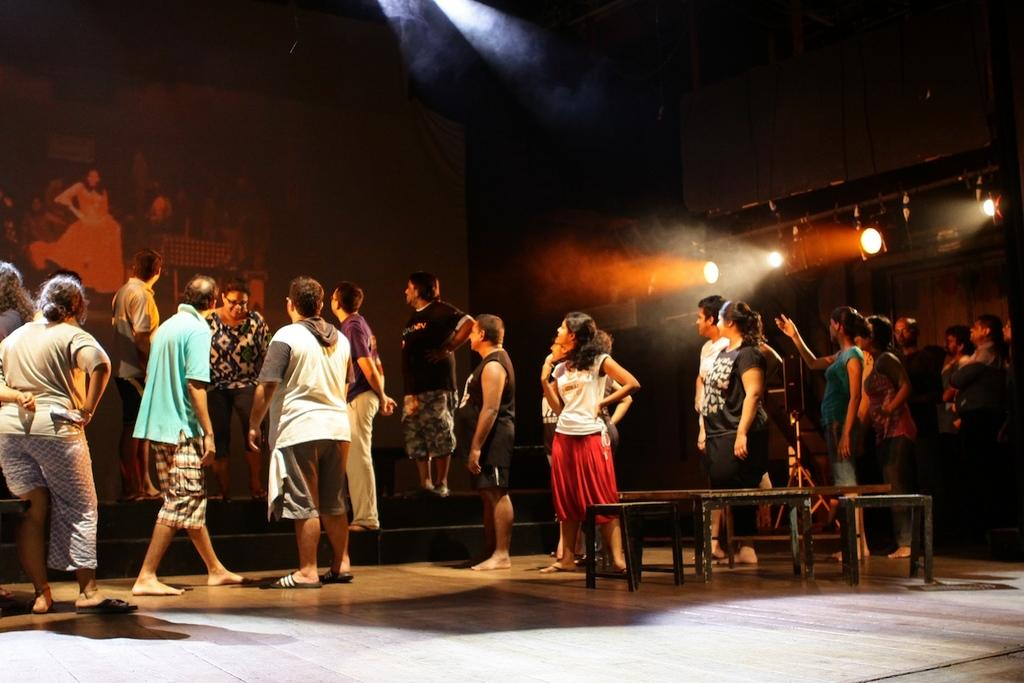How many people are in the image? There is a group of people in the image, but the exact number is not specified. What is located behind the group of people? There is a screen in the backdrop of the image. What can be seen attached to the wall in the image? Lights are attached to the wall in the image. How would you describe the lighting conditions in the image? The backdrop is dark, which suggests that the lighting is focused on the group of people and the screen. What type of wire is being used to wash the clothes in the image? There is no wire or washing activity present in the image. What class is being taught in the image? There is no indication of a class or any educational activity in the image. 